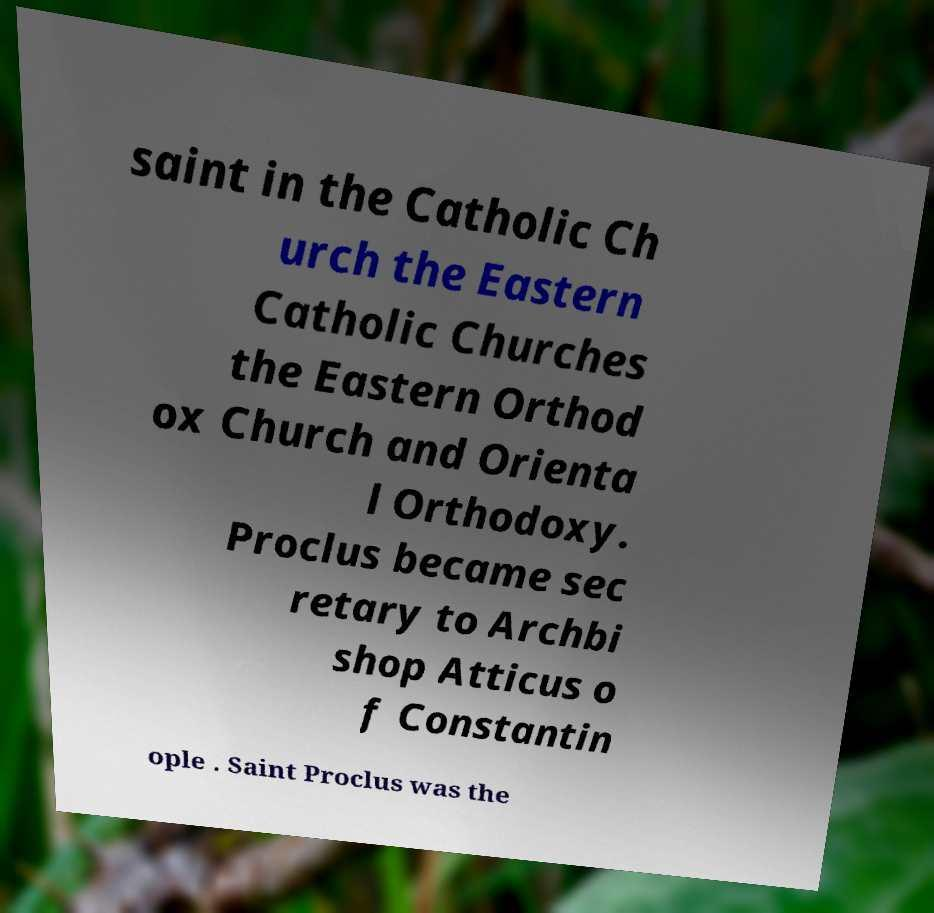Could you assist in decoding the text presented in this image and type it out clearly? saint in the Catholic Ch urch the Eastern Catholic Churches the Eastern Orthod ox Church and Orienta l Orthodoxy. Proclus became sec retary to Archbi shop Atticus o f Constantin ople . Saint Proclus was the 